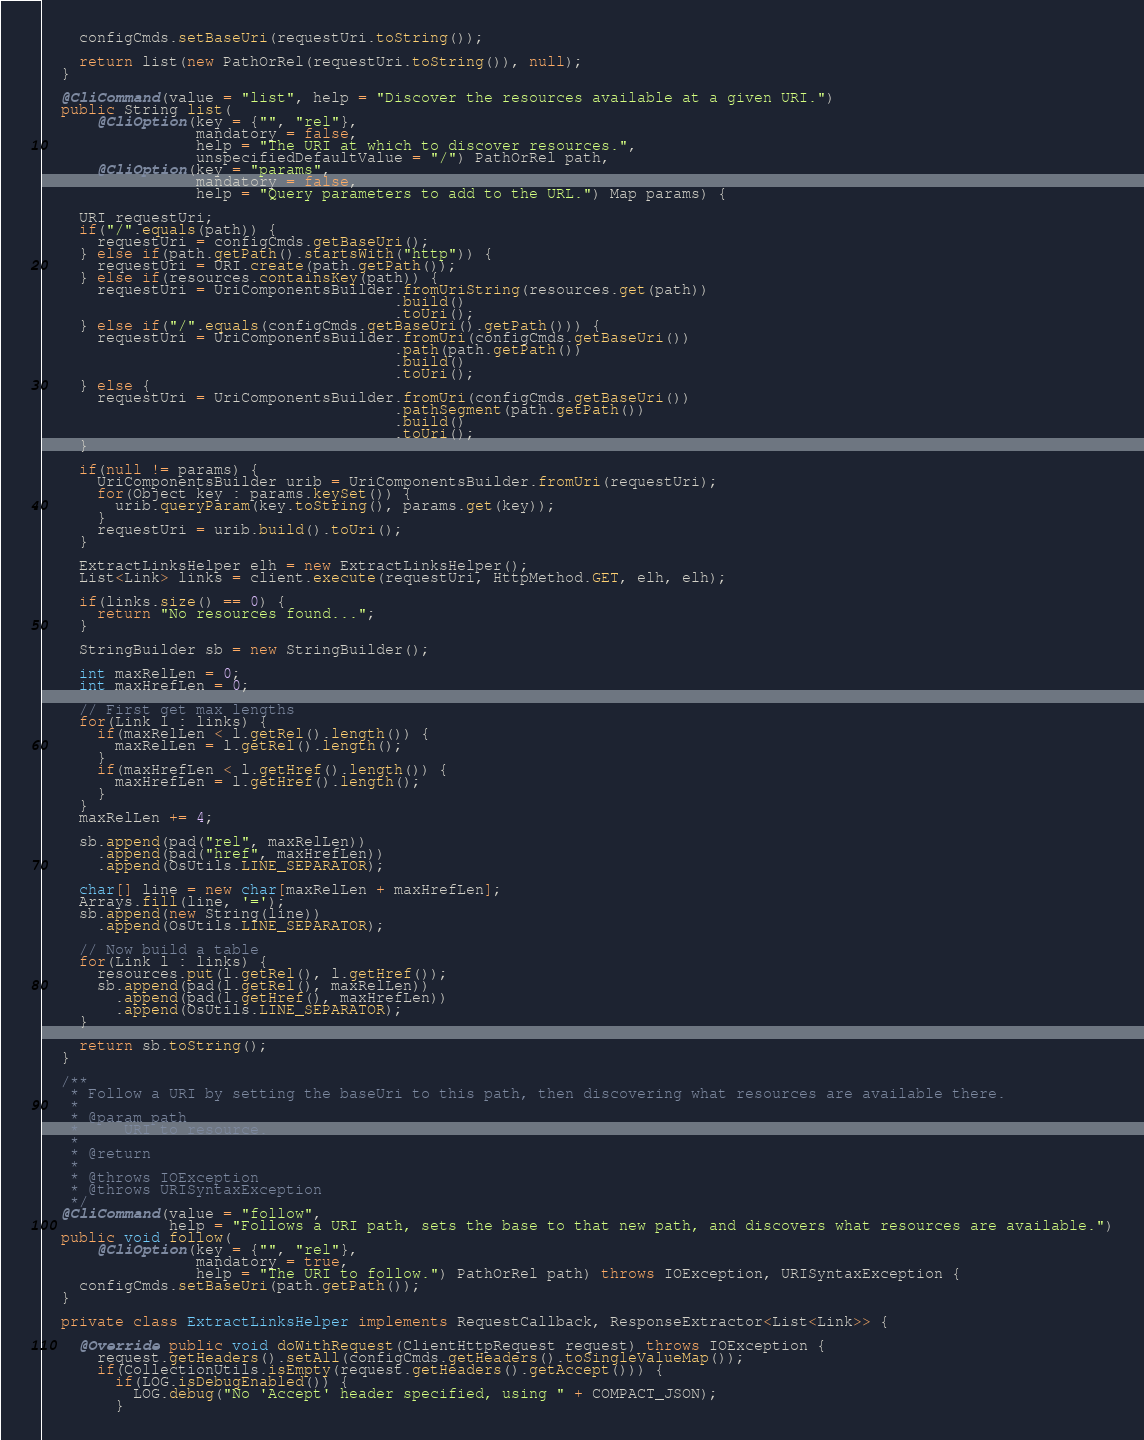<code> <loc_0><loc_0><loc_500><loc_500><_Java_>    configCmds.setBaseUri(requestUri.toString());

    return list(new PathOrRel(requestUri.toString()), null);
  }

  @CliCommand(value = "list", help = "Discover the resources available at a given URI.")
  public String list(
      @CliOption(key = {"", "rel"},
                 mandatory = false,
                 help = "The URI at which to discover resources.",
                 unspecifiedDefaultValue = "/") PathOrRel path,
      @CliOption(key = "params",
                 mandatory = false,
                 help = "Query parameters to add to the URL.") Map params) {

    URI requestUri;
    if("/".equals(path)) {
      requestUri = configCmds.getBaseUri();
    } else if(path.getPath().startsWith("http")) {
      requestUri = URI.create(path.getPath());
    } else if(resources.containsKey(path)) {
      requestUri = UriComponentsBuilder.fromUriString(resources.get(path))
                                       .build()
                                       .toUri();
    } else if("/".equals(configCmds.getBaseUri().getPath())) {
      requestUri = UriComponentsBuilder.fromUri(configCmds.getBaseUri())
                                       .path(path.getPath())
                                       .build()
                                       .toUri();
    } else {
      requestUri = UriComponentsBuilder.fromUri(configCmds.getBaseUri())
                                       .pathSegment(path.getPath())
                                       .build()
                                       .toUri();
    }

    if(null != params) {
      UriComponentsBuilder urib = UriComponentsBuilder.fromUri(requestUri);
      for(Object key : params.keySet()) {
        urib.queryParam(key.toString(), params.get(key));
      }
      requestUri = urib.build().toUri();
    }

    ExtractLinksHelper elh = new ExtractLinksHelper();
    List<Link> links = client.execute(requestUri, HttpMethod.GET, elh, elh);

    if(links.size() == 0) {
      return "No resources found...";
    }

    StringBuilder sb = new StringBuilder();

    int maxRelLen = 0;
    int maxHrefLen = 0;

    // First get max lengths
    for(Link l : links) {
      if(maxRelLen < l.getRel().length()) {
        maxRelLen = l.getRel().length();
      }
      if(maxHrefLen < l.getHref().length()) {
        maxHrefLen = l.getHref().length();
      }
    }
    maxRelLen += 4;

    sb.append(pad("rel", maxRelLen))
      .append(pad("href", maxHrefLen))
      .append(OsUtils.LINE_SEPARATOR);

    char[] line = new char[maxRelLen + maxHrefLen];
    Arrays.fill(line, '=');
    sb.append(new String(line))
      .append(OsUtils.LINE_SEPARATOR);

    // Now build a table
    for(Link l : links) {
      resources.put(l.getRel(), l.getHref());
      sb.append(pad(l.getRel(), maxRelLen))
        .append(pad(l.getHref(), maxHrefLen))
        .append(OsUtils.LINE_SEPARATOR);
    }

    return sb.toString();
  }

  /**
   * Follow a URI by setting the baseUri to this path, then discovering what resources are available there.
   *
   * @param path
   *     URI to resource.
   *
   * @return
   *
   * @throws IOException
   * @throws URISyntaxException
   */
  @CliCommand(value = "follow",
              help = "Follows a URI path, sets the base to that new path, and discovers what resources are available.")
  public void follow(
      @CliOption(key = {"", "rel"},
                 mandatory = true,
                 help = "The URI to follow.") PathOrRel path) throws IOException, URISyntaxException {
    configCmds.setBaseUri(path.getPath());
  }

  private class ExtractLinksHelper implements RequestCallback, ResponseExtractor<List<Link>> {

    @Override public void doWithRequest(ClientHttpRequest request) throws IOException {
      request.getHeaders().setAll(configCmds.getHeaders().toSingleValueMap());
      if(CollectionUtils.isEmpty(request.getHeaders().getAccept())) {
        if(LOG.isDebugEnabled()) {
          LOG.debug("No 'Accept' header specified, using " + COMPACT_JSON);
        }</code> 